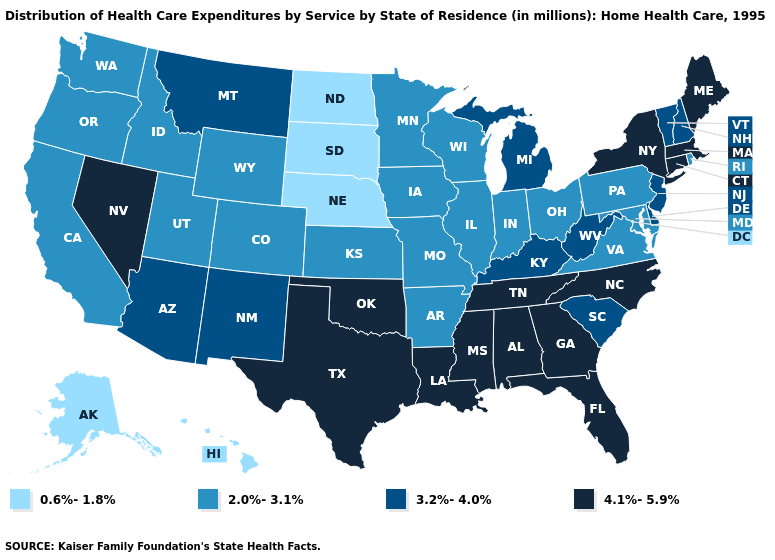Name the states that have a value in the range 0.6%-1.8%?
Answer briefly. Alaska, Hawaii, Nebraska, North Dakota, South Dakota. Among the states that border Wyoming , does Montana have the highest value?
Quick response, please. Yes. Which states have the highest value in the USA?
Give a very brief answer. Alabama, Connecticut, Florida, Georgia, Louisiana, Maine, Massachusetts, Mississippi, Nevada, New York, North Carolina, Oklahoma, Tennessee, Texas. Name the states that have a value in the range 0.6%-1.8%?
Concise answer only. Alaska, Hawaii, Nebraska, North Dakota, South Dakota. Name the states that have a value in the range 0.6%-1.8%?
Answer briefly. Alaska, Hawaii, Nebraska, North Dakota, South Dakota. Does Alaska have the lowest value in the West?
Be succinct. Yes. Name the states that have a value in the range 2.0%-3.1%?
Give a very brief answer. Arkansas, California, Colorado, Idaho, Illinois, Indiana, Iowa, Kansas, Maryland, Minnesota, Missouri, Ohio, Oregon, Pennsylvania, Rhode Island, Utah, Virginia, Washington, Wisconsin, Wyoming. What is the lowest value in the MidWest?
Be succinct. 0.6%-1.8%. Does Texas have the highest value in the USA?
Write a very short answer. Yes. Name the states that have a value in the range 2.0%-3.1%?
Answer briefly. Arkansas, California, Colorado, Idaho, Illinois, Indiana, Iowa, Kansas, Maryland, Minnesota, Missouri, Ohio, Oregon, Pennsylvania, Rhode Island, Utah, Virginia, Washington, Wisconsin, Wyoming. Among the states that border South Dakota , which have the lowest value?
Write a very short answer. Nebraska, North Dakota. What is the highest value in the USA?
Short answer required. 4.1%-5.9%. Is the legend a continuous bar?
Quick response, please. No. How many symbols are there in the legend?
Answer briefly. 4. What is the value of New York?
Answer briefly. 4.1%-5.9%. 